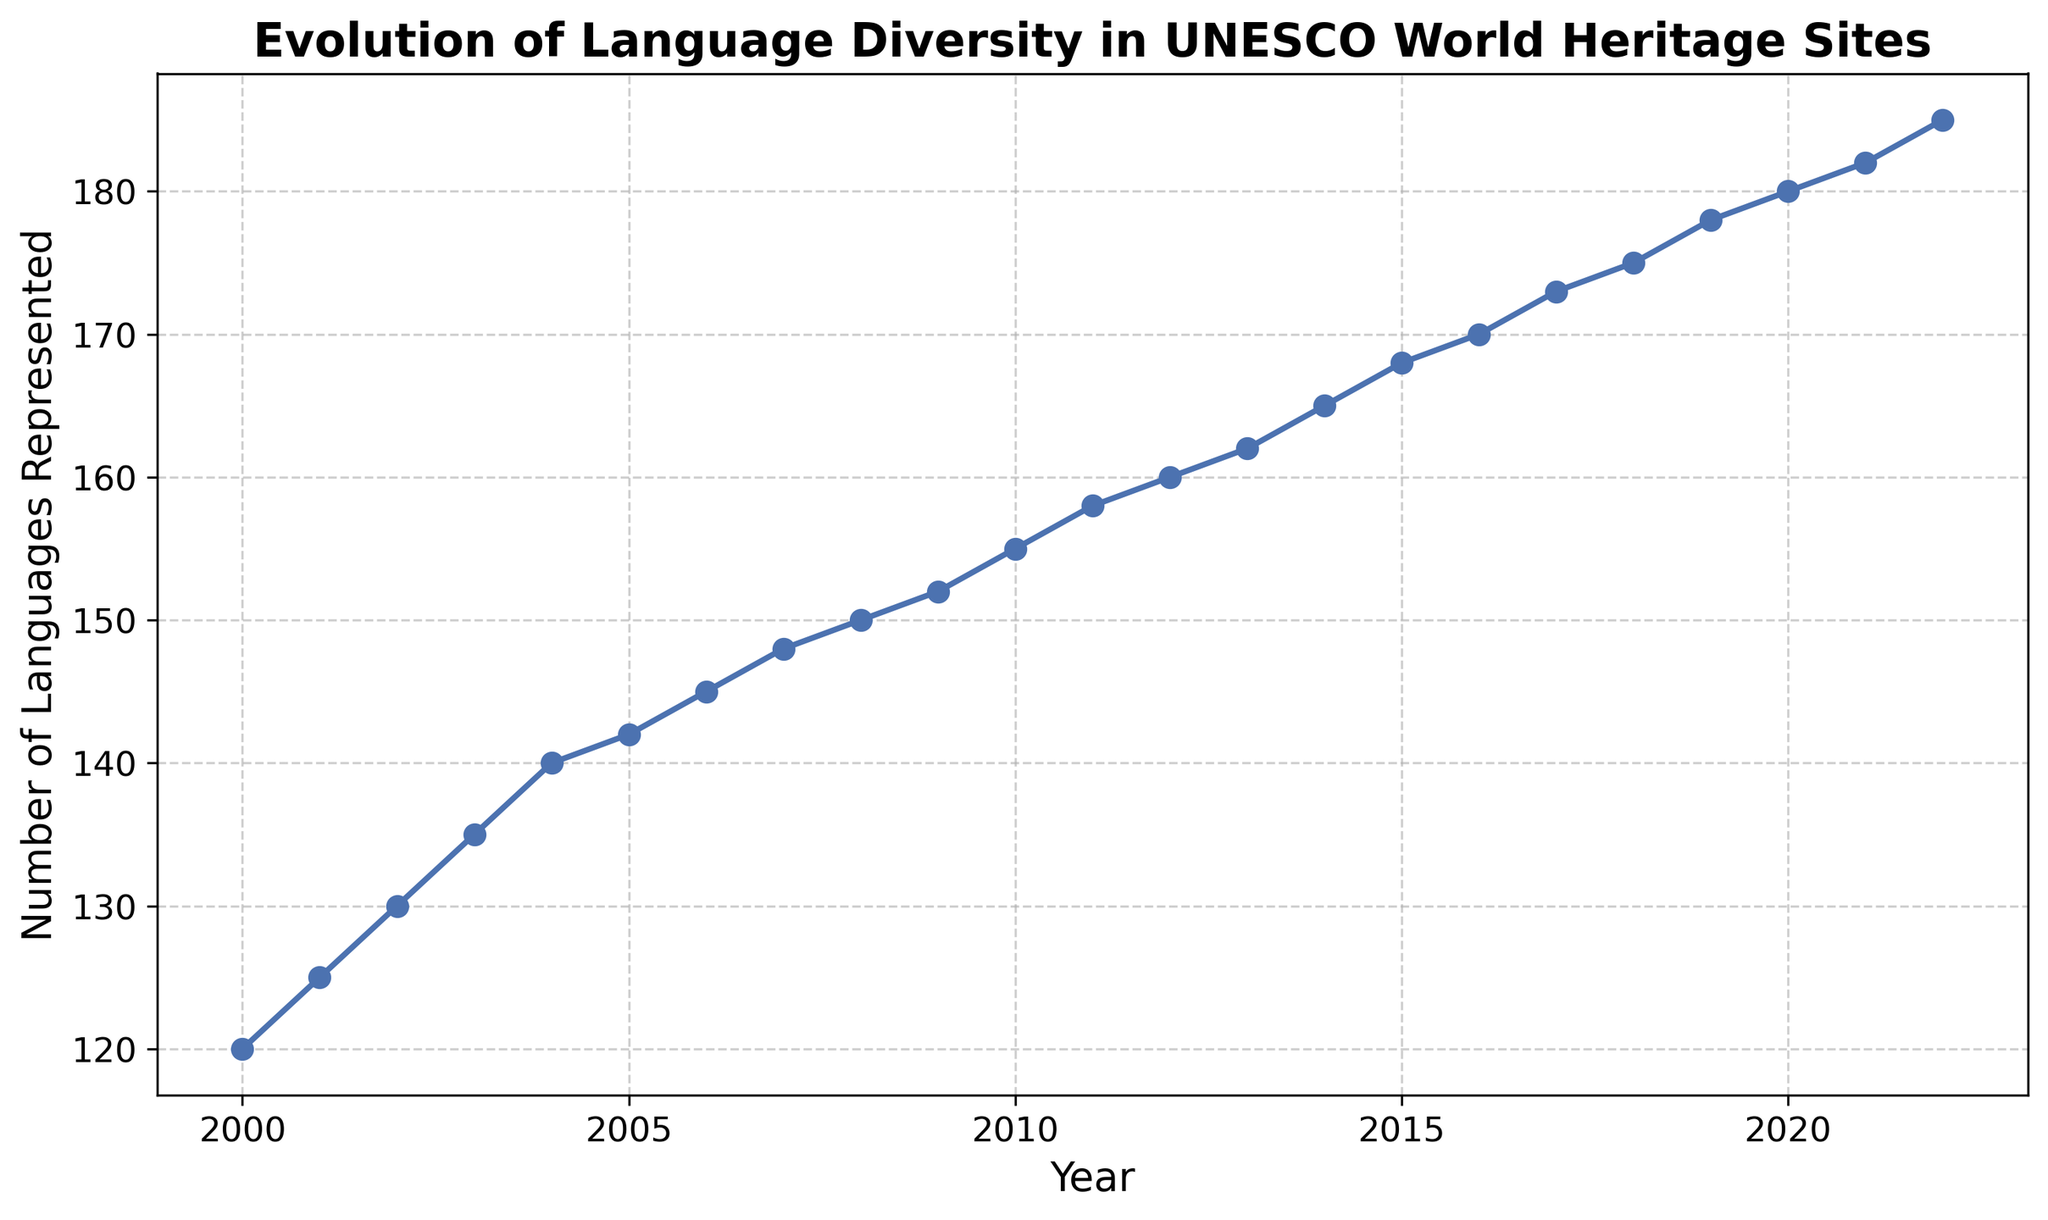What is the number of languages represented in UNESCO World Heritage Sites in 2000? Look at the point on the line chart corresponding to the year 2000 and read the number of languages represented.
Answer: 120 By how many languages did the representation increase from 2000 to 2022? Subtract the number of languages represented in 2000 from the number represented in 2022: 185 - 120.
Answer: 65 Which year saw the highest number of languages represented? Find the peak point on the line chart; it corresponds to the year 2022.
Answer: 2022 Between which two consecutive years did the number of languages represented increase by the greatest amount? Observe the slopes of the line segments; the steepest line segment between two consecutive years indicates the greatest increase. It appears to be from 2004 to 2005. Calculate: 142 - 140.
Answer: 2004-2005 How many years did it take for the number of languages represented to increase from 150 to 180? Identify the years when languages represented were 150 (2008) and 180 (2020) and subtract the earlier year from the later year: 2020 - 2008.
Answer: 12 What is the average number of languages represented between 2010 and 2020? Sum the number of languages represented between the years 2010 (155) and 2020 (180) and then divide by the number of years (11 inclusive): (155 + 158 + 160 + 162 + 165 + 168 + 170 + 173 + 175 + 178 + 180) / 11
Answer: 168 Compare the number of languages represented in 2015 and 2018. Which year had more? Observe the values on the line chart for the years 2015 (168) and 2018 (175) and compare: 175 is greater than 168.
Answer: 2018 What is the general trend observed in the line chart? Observe the overall direction in which the line chart moves. The line chart shows a consistently upward trend, indicating the number of languages represented is increasing over time.
Answer: Increasing How many years after 2000 did it take to reach over 150 languages represented? Determine the year when the number of languages represented first exceeds 150 from the chart, which is 2008, and calculate the difference from 2000: 2008 - 2000.
Answer: 8 Between 2006 and 2010, how many languages were added to the representation? Subtract the number of languages represented in 2006 from the number represented in 2010: 155 - 145.
Answer: 10 